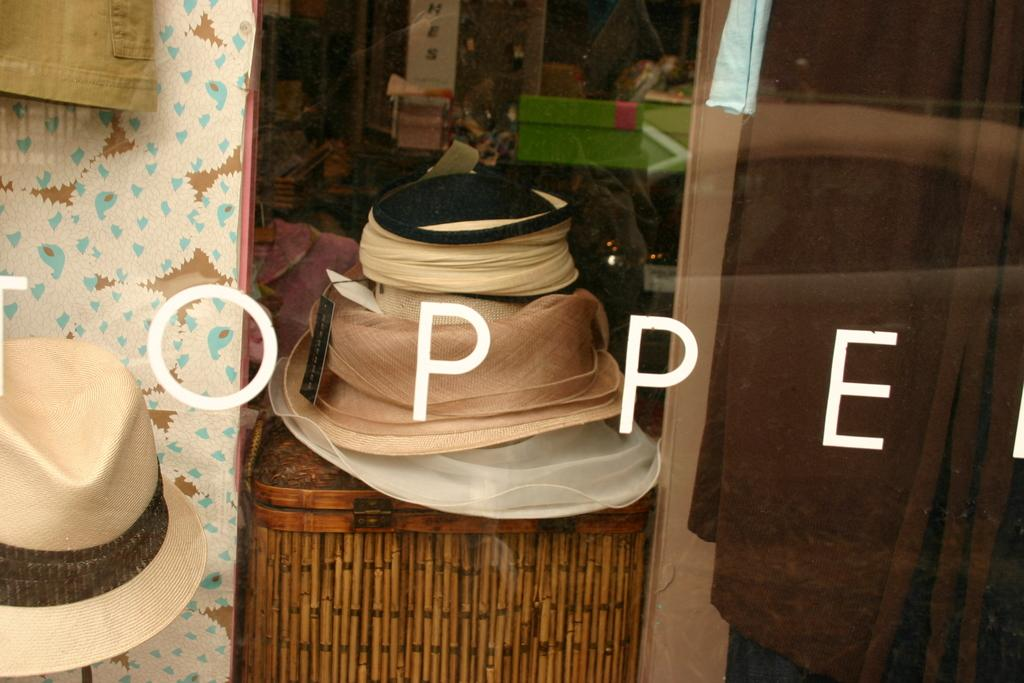What type of accessory is present in the image? There are hats in the image. What type of container is visible in the image? There is a wooden box in the image. Can you describe any other objects in the image? There are additional unspecified objects in the image. How is text incorporated into the image? There is edited text in the image. What type of stamp can be seen on the wooden box in the image? There is no stamp present on the wooden box in the image. What is the purpose of the hats in the image? The purpose of the hats in the image cannot be determined without additional context. 